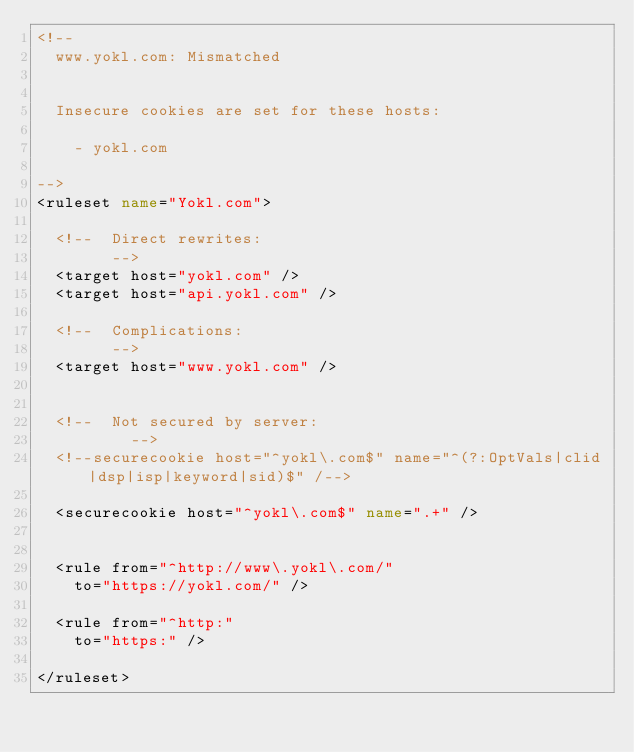<code> <loc_0><loc_0><loc_500><loc_500><_XML_><!--
	www.yokl.com: Mismatched


	Insecure cookies are set for these hosts:

		- yokl.com

-->
<ruleset name="Yokl.com">

	<!--	Direct rewrites:
				-->
	<target host="yokl.com" />
	<target host="api.yokl.com" />

	<!--	Complications:
				-->
	<target host="www.yokl.com" />


	<!--	Not secured by server:
					-->
	<!--securecookie host="^yokl\.com$" name="^(?:OptVals|clid|dsp|isp|keyword|sid)$" /-->

	<securecookie host="^yokl\.com$" name=".+" />


	<rule from="^http://www\.yokl\.com/"
		to="https://yokl.com/" />

	<rule from="^http:"
		to="https:" />

</ruleset>
</code> 